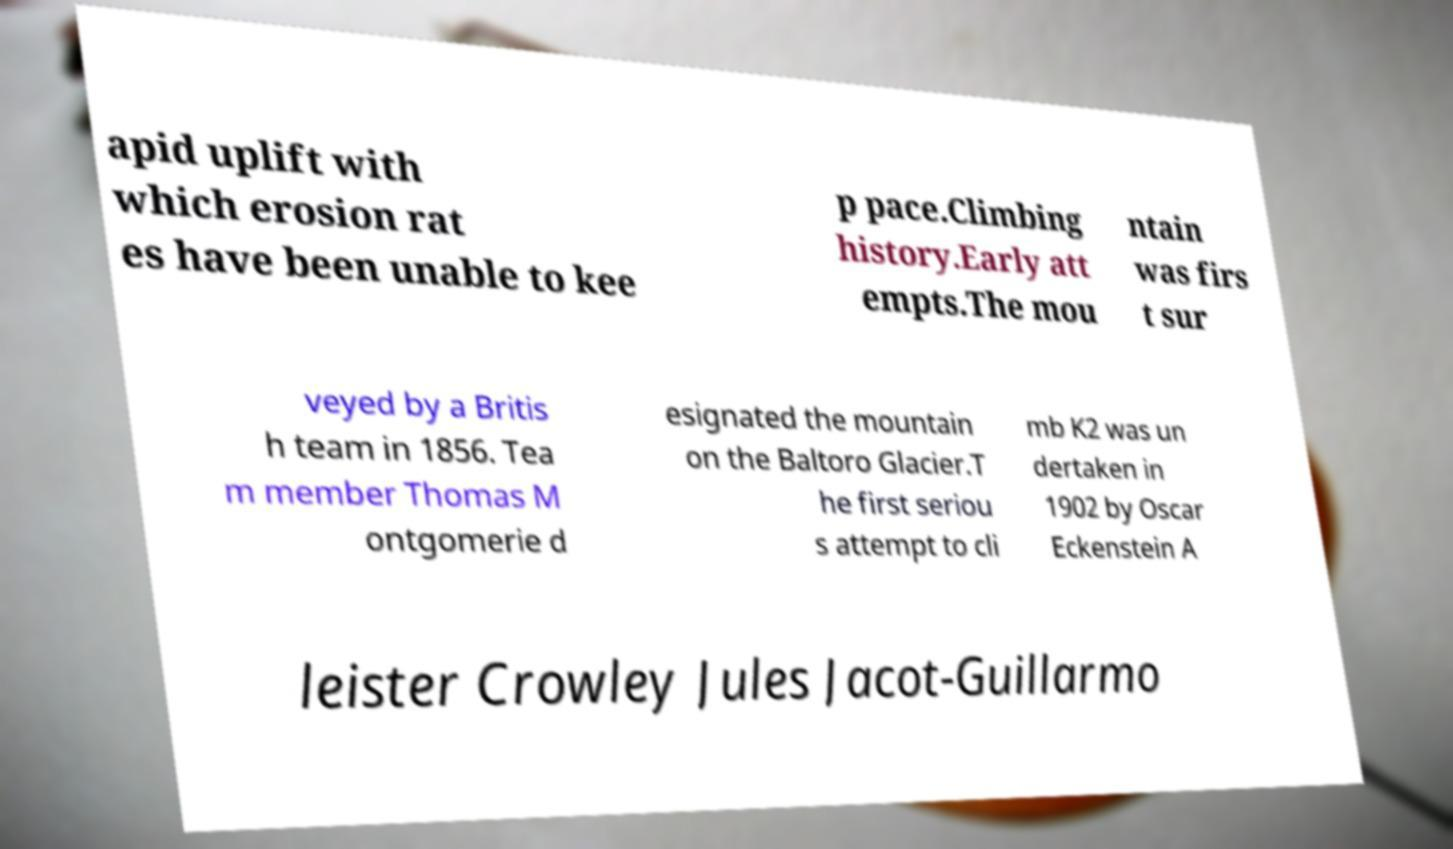I need the written content from this picture converted into text. Can you do that? apid uplift with which erosion rat es have been unable to kee p pace.Climbing history.Early att empts.The mou ntain was firs t sur veyed by a Britis h team in 1856. Tea m member Thomas M ontgomerie d esignated the mountain on the Baltoro Glacier.T he first seriou s attempt to cli mb K2 was un dertaken in 1902 by Oscar Eckenstein A leister Crowley Jules Jacot-Guillarmo 